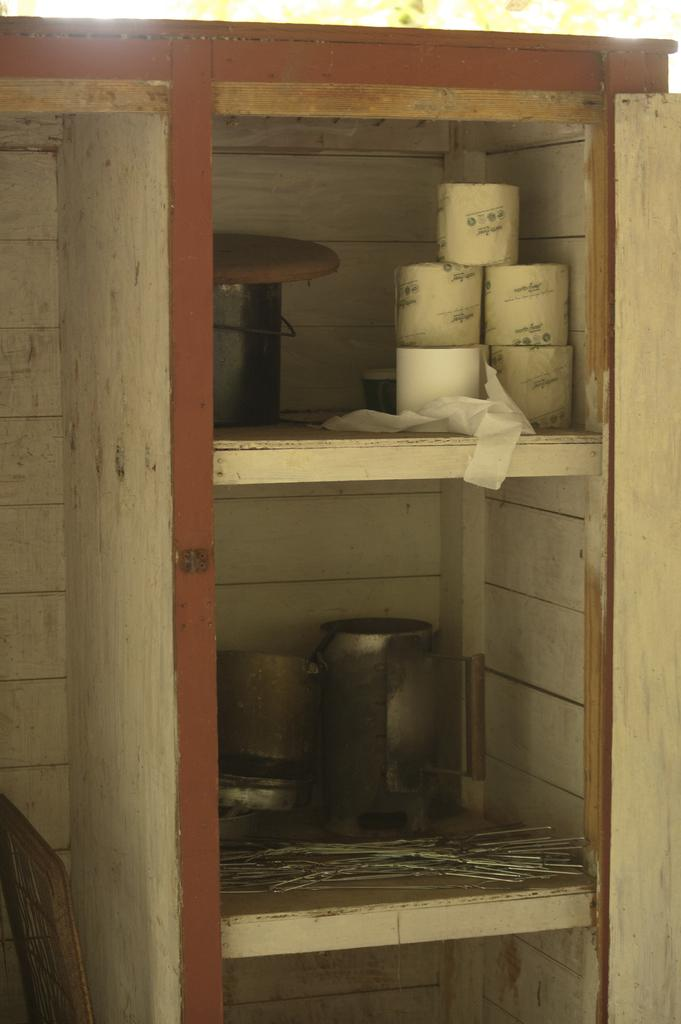What type of paper is present in the image? There are tissue papers in the image. What is the material of the bowl in the image? The bowl in the image is made of steel. What can be found on a rack in the image? There are other objects on a rack in the image. What type of wall is on the left side of the image? There is a wooden wall on the left side of the image. What is visible at the top of the image? There is a tree visible at the top of the image. How many crayons are on the wooden wall in the image? There are no crayons present in the image. What is the value of the dime on the rack in the image? There is no dime present in the image. 